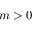Convert formula to latex. <formula><loc_0><loc_0><loc_500><loc_500>m > 0</formula> 